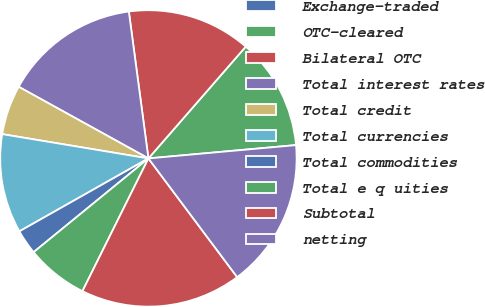Convert chart. <chart><loc_0><loc_0><loc_500><loc_500><pie_chart><fcel>Exchange-traded<fcel>OTC-cleared<fcel>Bilateral OTC<fcel>Total interest rates<fcel>Total credit<fcel>Total currencies<fcel>Total commodities<fcel>Total e q uities<fcel>Subtotal<fcel>netting<nl><fcel>0.01%<fcel>12.16%<fcel>13.51%<fcel>14.86%<fcel>5.41%<fcel>10.81%<fcel>2.71%<fcel>6.76%<fcel>17.56%<fcel>16.21%<nl></chart> 